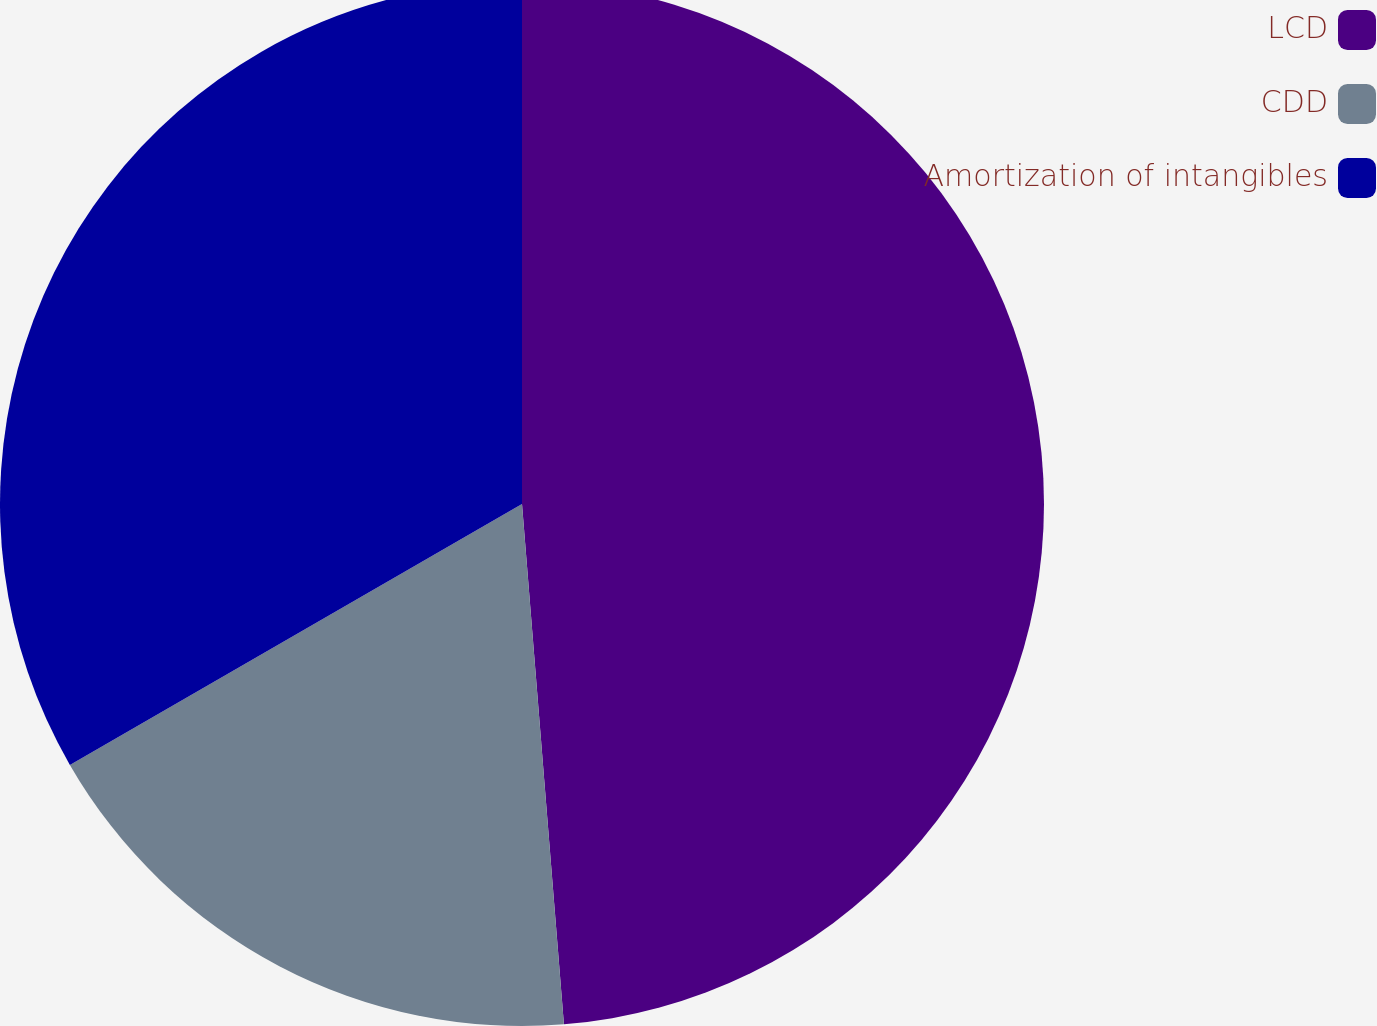<chart> <loc_0><loc_0><loc_500><loc_500><pie_chart><fcel>LCD<fcel>CDD<fcel>Amortization of intangibles<nl><fcel>48.72%<fcel>17.95%<fcel>33.33%<nl></chart> 